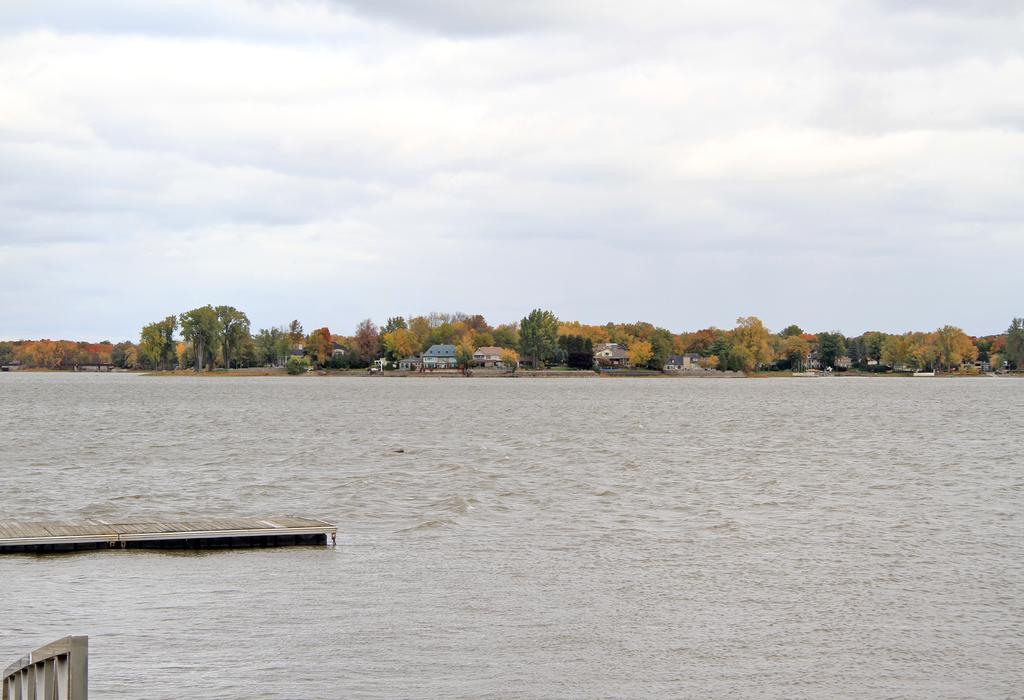Could you give a brief overview of what you see in this image? In this image we can see a dock and a water body. In the background, we can see buildings and trees. At the top of the image, we can see the sky with clouds. It seems like a railing in the left bottom of the image. 